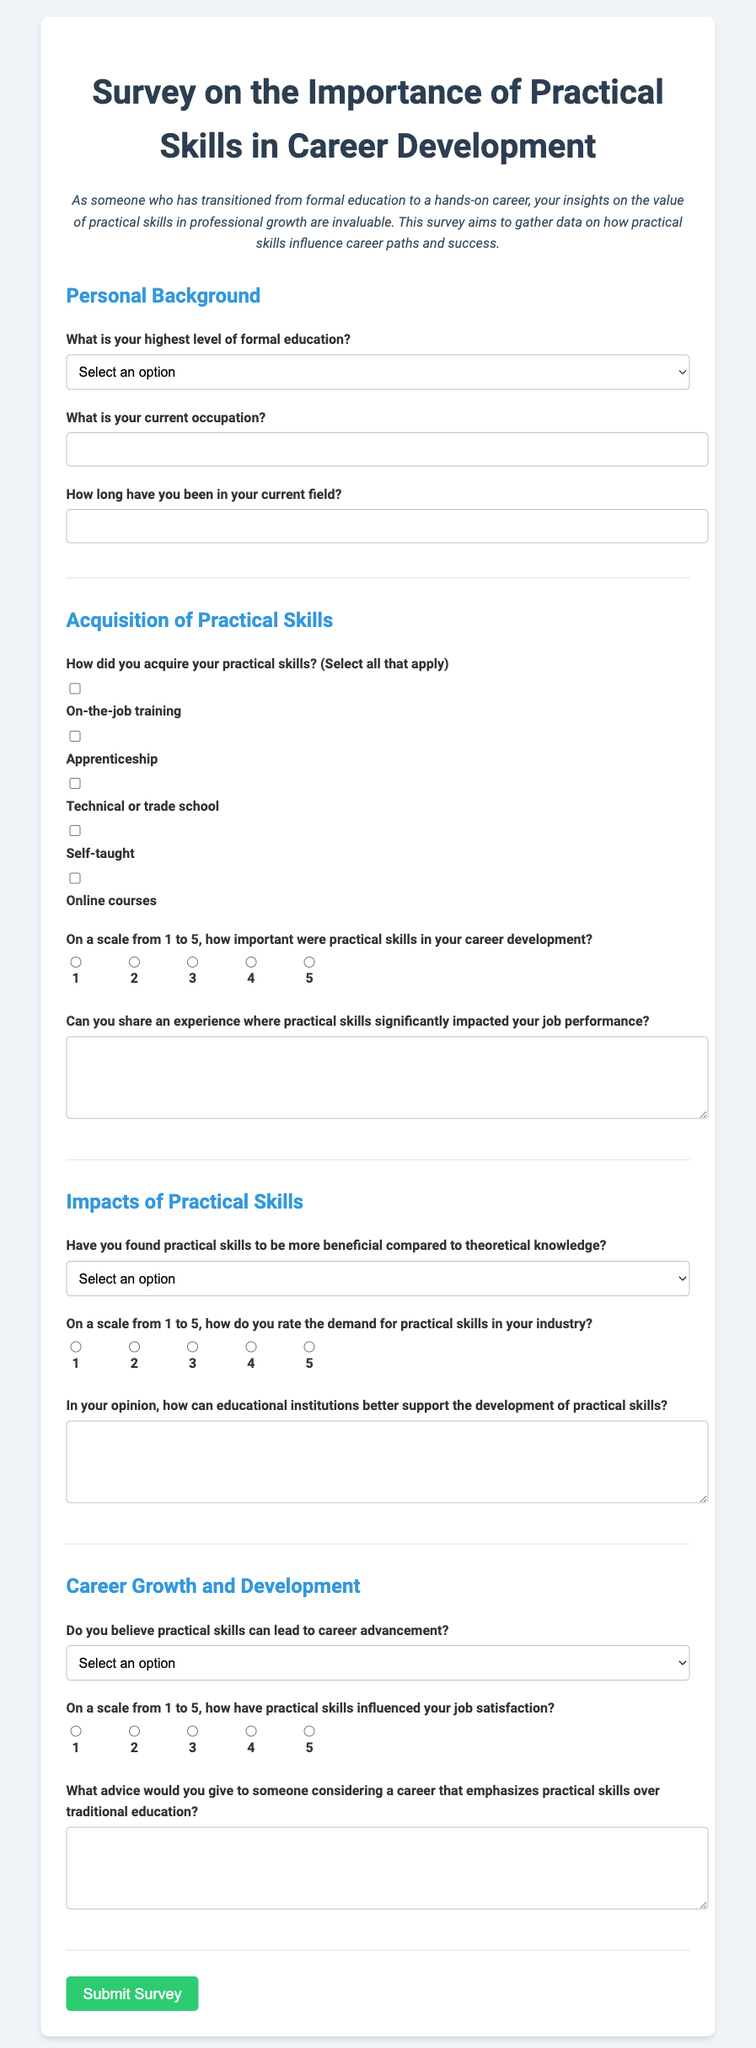What is the title of the survey? The title of the survey is stated in the document, which is "Survey on the Importance of Practical Skills in Career Development."
Answer: Survey on the Importance of Practical Skills in Career Development How many sections are in the survey? The survey is divided into four sections: Personal Background, Acquisition of Practical Skills, Impacts of Practical Skills, and Career Growth and Development.
Answer: Four What rating scale is used to assess the importance of practical skills? The document mentions a scale from 1 to 5 used for gauging the significance of practical skills in career development.
Answer: 1 to 5 What option is provided for the current occupation question? The current occupation question provides an input field, allowing respondents to write their occupation.
Answer: Input field What is one method listed for acquiring practical skills? The document provides several methods for acquiring practical skills, one of which is "On-the-job training."
Answer: On-the-job training Do respondents have the option to express their thoughts on educational support for practical skills? Yes, respondents can provide feedback through a textarea question on how educational institutions can better support practical skills development.
Answer: Yes What is the last question category in the survey? The last category in the survey focuses on "Career Growth and Development."
Answer: Career Growth and Development How does the survey ask about job satisfaction influence? The survey asks respondents to rate their job satisfaction influenced by practical skills on a scale from 1 to 5.
Answer: Scale from 1 to 5 Is there a question about career advancement in the survey? Yes, there is a question that inquires whether practical skills can lead to career advancement.
Answer: Yes 